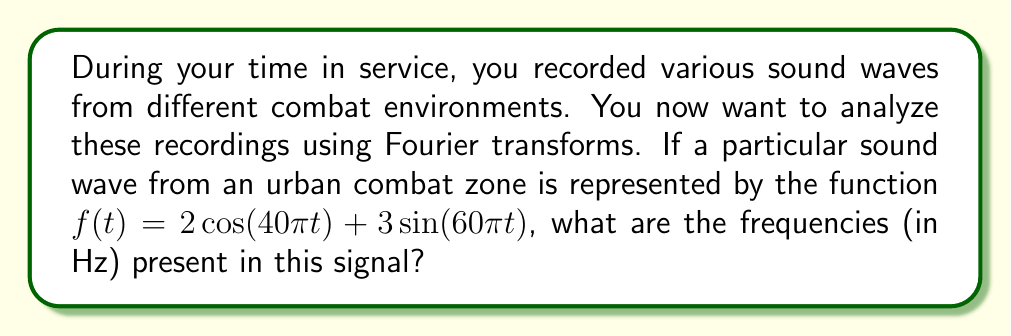Can you answer this question? To solve this problem, we need to understand the relationship between the angular frequency $\omega$ in the trigonometric functions and the actual frequency $f$ in Hertz. The relationship is given by:

$$\omega = 2\pi f$$

Let's analyze each term in the given function:

1. First term: $2\cos(40\pi t)$
   The angular frequency here is $40\pi$. To find the frequency in Hz:
   $$40\pi = 2\pi f$$
   $$f = \frac{40\pi}{2\pi} = 20 \text{ Hz}$$

2. Second term: $3\sin(60\pi t)$
   The angular frequency here is $60\pi$. To find the frequency in Hz:
   $$60\pi = 2\pi f$$
   $$f = \frac{60\pi}{2\pi} = 30 \text{ Hz}$$

Therefore, the sound wave contains two distinct frequencies: 20 Hz and 30 Hz.

This analysis demonstrates how Fourier transforms can decompose a complex waveform into its constituent frequencies, which is crucial for understanding and categorizing sounds in different combat environments.
Answer: The frequencies present in the signal are 20 Hz and 30 Hz. 